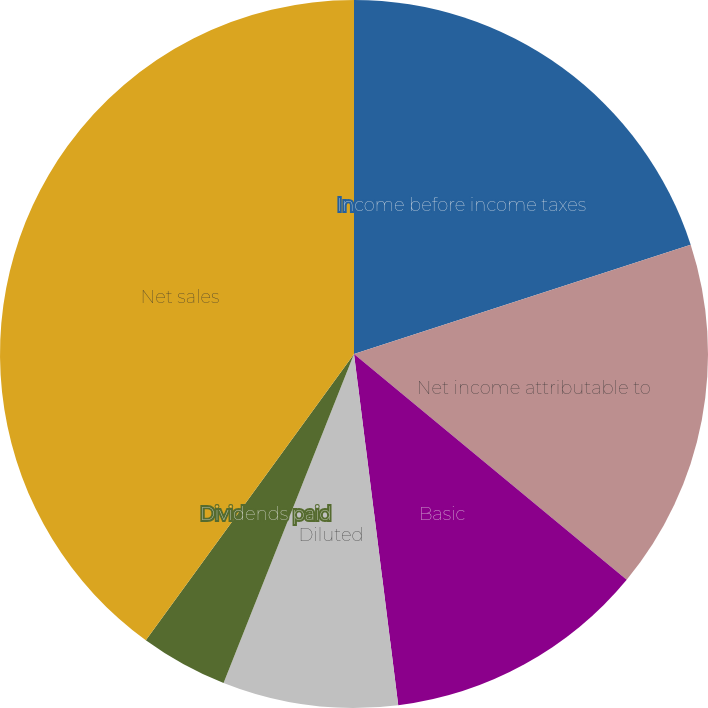Convert chart to OTSL. <chart><loc_0><loc_0><loc_500><loc_500><pie_chart><fcel>Income before income taxes<fcel>Net income attributable to<fcel>Basic<fcel>Diluted<fcel>Dividends declared<fcel>Dividends paid<fcel>Net sales<nl><fcel>20.0%<fcel>16.0%<fcel>12.0%<fcel>8.0%<fcel>0.0%<fcel>4.0%<fcel>39.99%<nl></chart> 